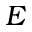<formula> <loc_0><loc_0><loc_500><loc_500>E</formula> 